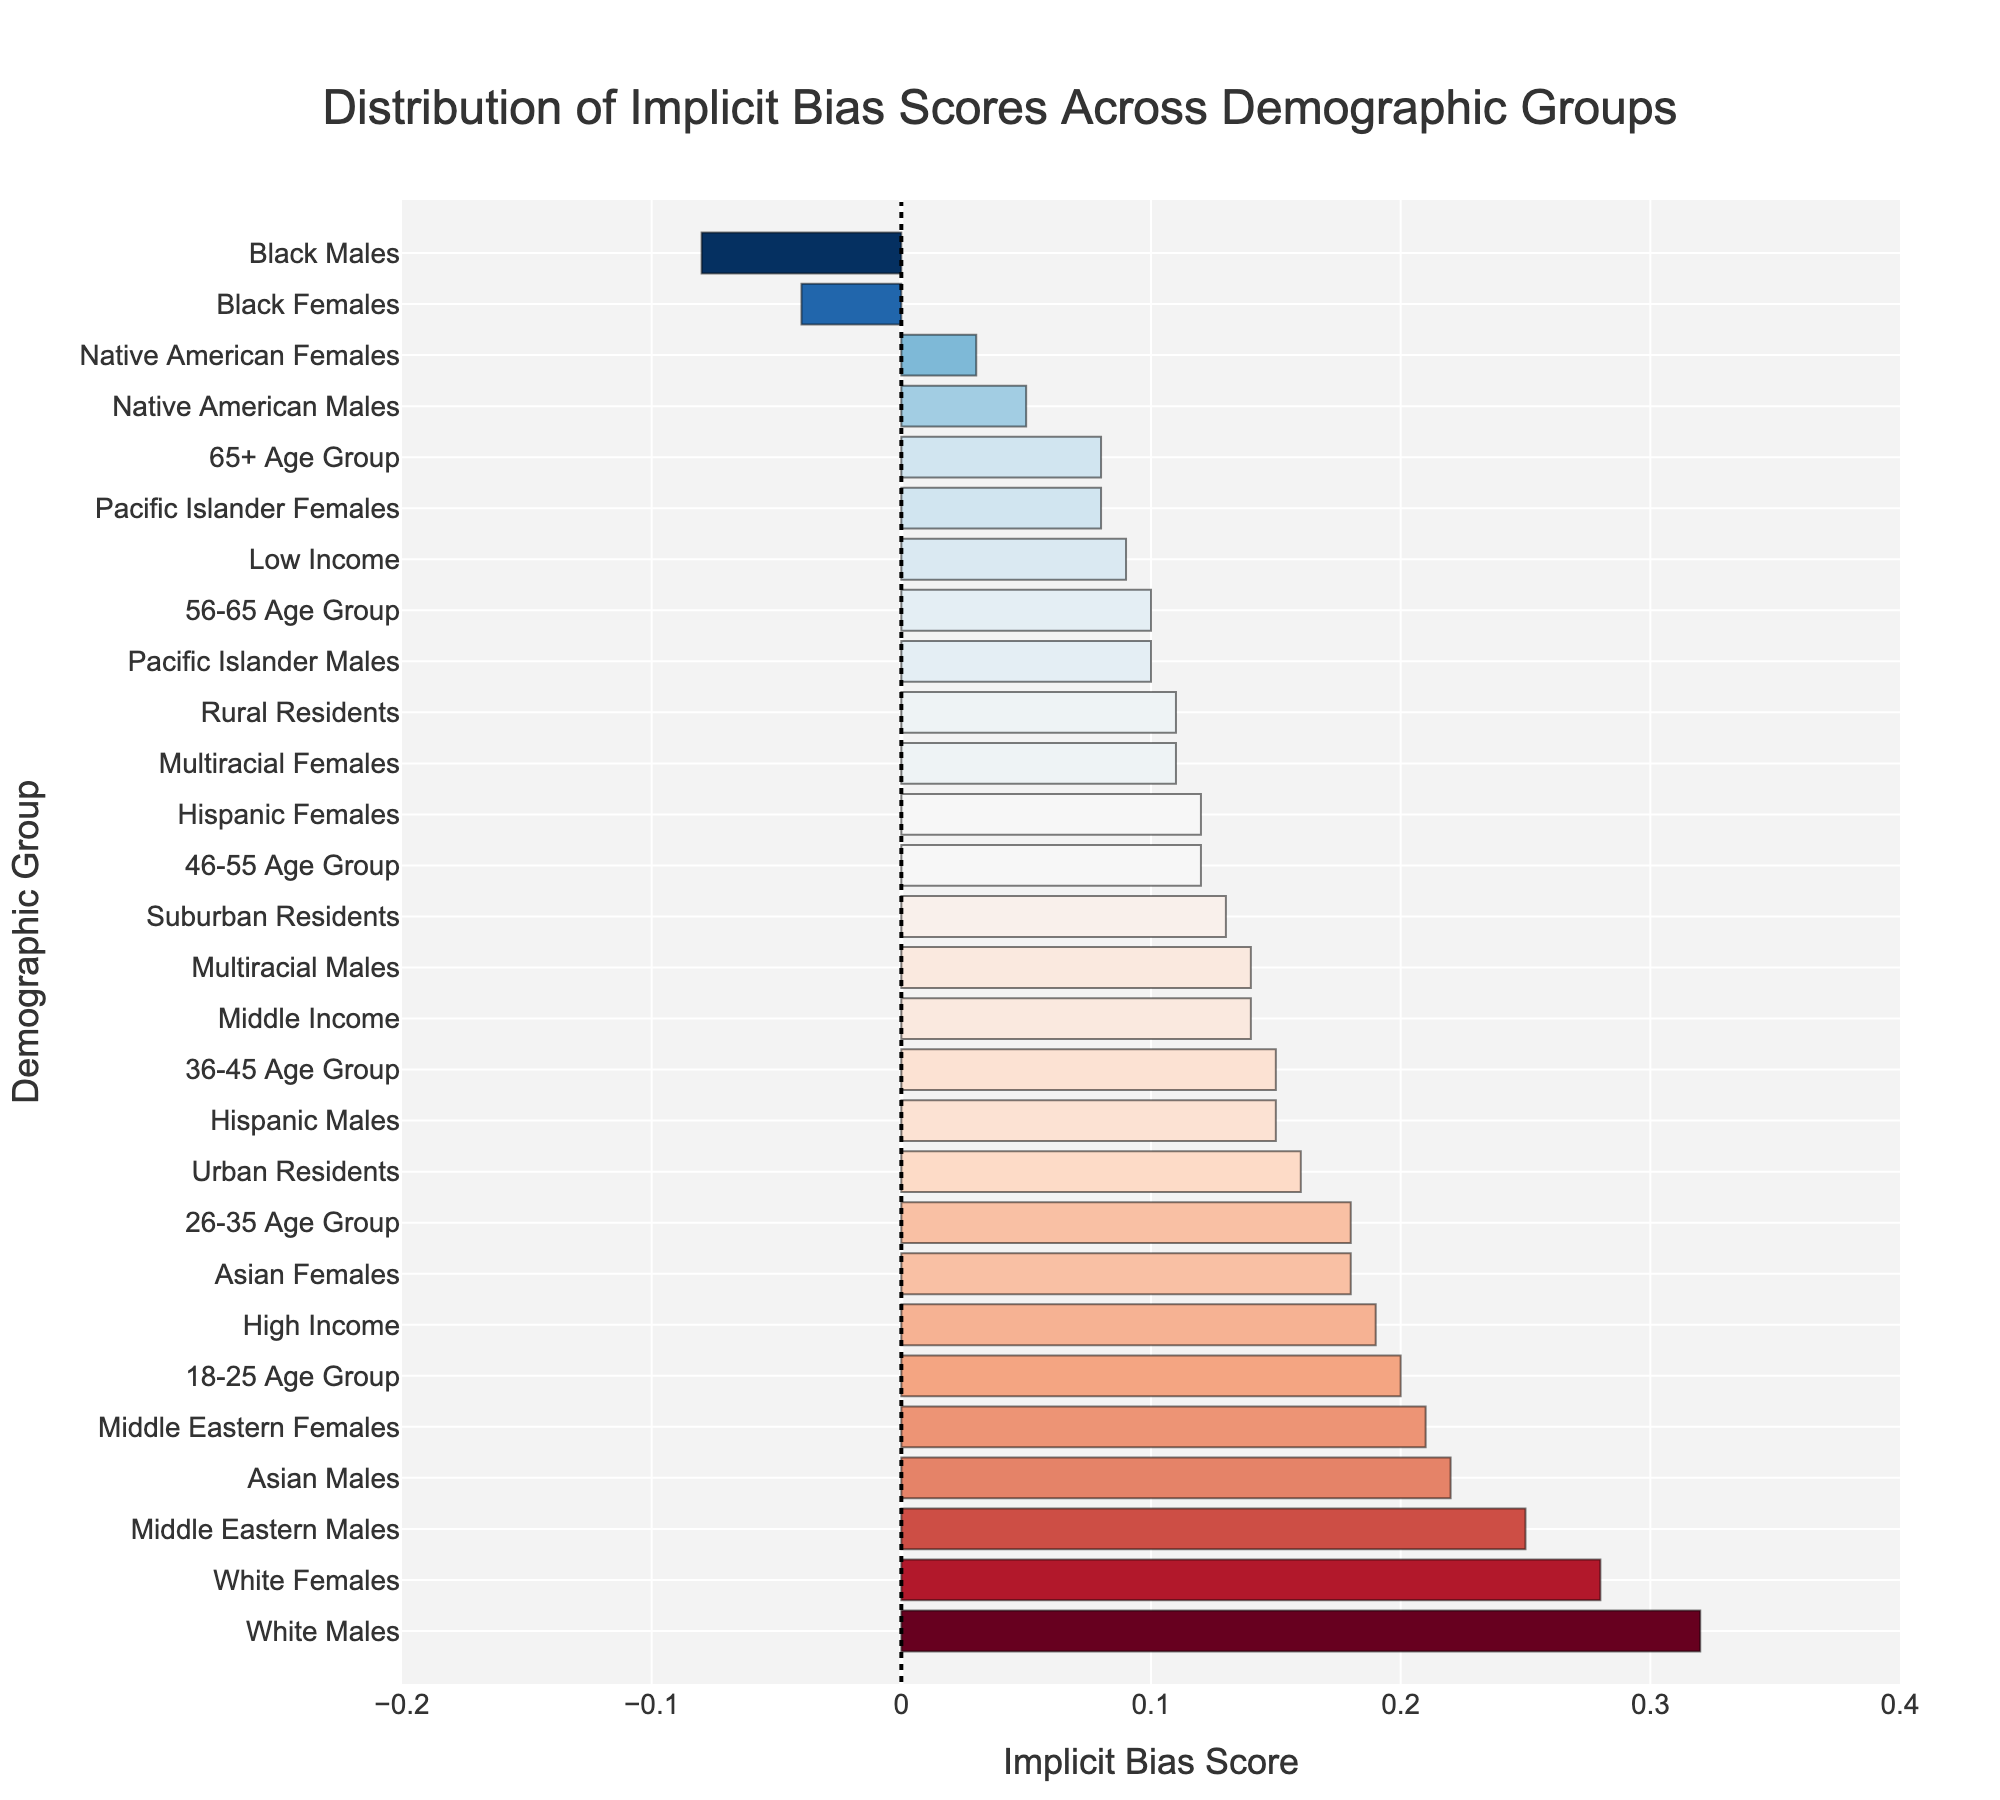What group has the highest implicit bias score? To identify the group with the highest implicit bias score, look for the bar that extends farthest to the right. The "White Males" group has a score of 0.32.
Answer: White Males Which demographic group has the lowest implicit bias score? To find the group with the lowest score, look for the bar that extends farthest to the left. The "Black Males" group has a score of -0.08.
Answer: Black Males What is the implicit bias score difference between White Males and Black Males? To calculate the difference, subtract the implicit bias score of Black Males from that of White Males (0.32 - (-0.08) = 0.32 + 0.08 = 0.40).
Answer: 0.40 Which demographic groups have a negative implicit bias score? Look for groups whose bars extend to the left of the reference line at x=0. Black Males and Black Females both have negative scores.
Answer: Black Males, Black Females Is the implicit bias score of White Females higher or lower than that of Asian Males? Compare the lengths of the bars for White Females and Asian Males. White Females have a score of 0.28, and Asian Males have a score of 0.22. The White Females' score is higher.
Answer: Higher What is the median implicit bias score of all groups shown? To find the median, list all implicit bias scores in ascending order and find the middle value. Since there are 27 groups, the median is the 14th value from either end. The scores listed in ascending order are [-0.08, -0.04, 0.03, 0.05, 0.08, 0.08, 0.10, 0.10, 0.11, 0.12, 0.12, 0.14, 0.14, 0.15, 0.18, 0.18, 0.20, 0.20, 0.21, 0.22, 0.25, 0.28, 0.32]. The 14th score is 0.15.
Answer: 0.15 Among all age groups, which one has the highest implicit bias score? Identify the bar that is labeled with an age group and extends farthest to the right. The "18-25 Age Group" has the highest score of 0.20.
Answer: 18-25 Age Group Compare the implicit bias scores of Urban, Suburban, and Rural Residents. Which has the highest score? Look at the bars labeled "Urban Residents", "Suburban Residents", and "Rural Residents". Urban Residents have the highest score at 0.16.
Answer: Urban Residents How many demographic groups have an implicit bias score greater than 0.20? Count the number of bars that extend beyond the 0.20 mark on the x-axis. The groups are White Males (0.32), White Females (0.28), Middle Eastern Males (0.25), and 18-25 Age Group (0.20), totaling 4 groups.
Answer: 4 What is the implicit bias score for the Middle Income group? Locate the bar labeled "Middle Income". The score for Middle Income is 0.14.
Answer: 0.14 